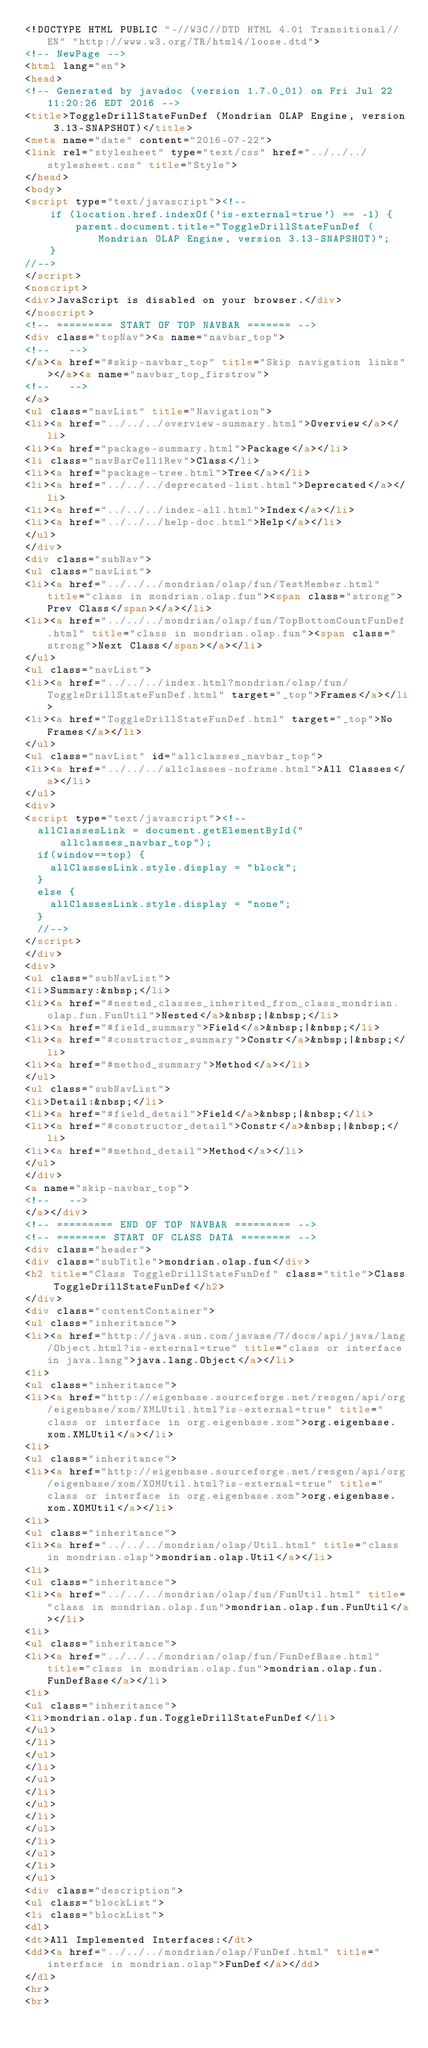<code> <loc_0><loc_0><loc_500><loc_500><_HTML_><!DOCTYPE HTML PUBLIC "-//W3C//DTD HTML 4.01 Transitional//EN" "http://www.w3.org/TR/html4/loose.dtd">
<!-- NewPage -->
<html lang="en">
<head>
<!-- Generated by javadoc (version 1.7.0_01) on Fri Jul 22 11:20:26 EDT 2016 -->
<title>ToggleDrillStateFunDef (Mondrian OLAP Engine, version 3.13-SNAPSHOT)</title>
<meta name="date" content="2016-07-22">
<link rel="stylesheet" type="text/css" href="../../../stylesheet.css" title="Style">
</head>
<body>
<script type="text/javascript"><!--
    if (location.href.indexOf('is-external=true') == -1) {
        parent.document.title="ToggleDrillStateFunDef (Mondrian OLAP Engine, version 3.13-SNAPSHOT)";
    }
//-->
</script>
<noscript>
<div>JavaScript is disabled on your browser.</div>
</noscript>
<!-- ========= START OF TOP NAVBAR ======= -->
<div class="topNav"><a name="navbar_top">
<!--   -->
</a><a href="#skip-navbar_top" title="Skip navigation links"></a><a name="navbar_top_firstrow">
<!--   -->
</a>
<ul class="navList" title="Navigation">
<li><a href="../../../overview-summary.html">Overview</a></li>
<li><a href="package-summary.html">Package</a></li>
<li class="navBarCell1Rev">Class</li>
<li><a href="package-tree.html">Tree</a></li>
<li><a href="../../../deprecated-list.html">Deprecated</a></li>
<li><a href="../../../index-all.html">Index</a></li>
<li><a href="../../../help-doc.html">Help</a></li>
</ul>
</div>
<div class="subNav">
<ul class="navList">
<li><a href="../../../mondrian/olap/fun/TestMember.html" title="class in mondrian.olap.fun"><span class="strong">Prev Class</span></a></li>
<li><a href="../../../mondrian/olap/fun/TopBottomCountFunDef.html" title="class in mondrian.olap.fun"><span class="strong">Next Class</span></a></li>
</ul>
<ul class="navList">
<li><a href="../../../index.html?mondrian/olap/fun/ToggleDrillStateFunDef.html" target="_top">Frames</a></li>
<li><a href="ToggleDrillStateFunDef.html" target="_top">No Frames</a></li>
</ul>
<ul class="navList" id="allclasses_navbar_top">
<li><a href="../../../allclasses-noframe.html">All Classes</a></li>
</ul>
<div>
<script type="text/javascript"><!--
  allClassesLink = document.getElementById("allclasses_navbar_top");
  if(window==top) {
    allClassesLink.style.display = "block";
  }
  else {
    allClassesLink.style.display = "none";
  }
  //-->
</script>
</div>
<div>
<ul class="subNavList">
<li>Summary:&nbsp;</li>
<li><a href="#nested_classes_inherited_from_class_mondrian.olap.fun.FunUtil">Nested</a>&nbsp;|&nbsp;</li>
<li><a href="#field_summary">Field</a>&nbsp;|&nbsp;</li>
<li><a href="#constructor_summary">Constr</a>&nbsp;|&nbsp;</li>
<li><a href="#method_summary">Method</a></li>
</ul>
<ul class="subNavList">
<li>Detail:&nbsp;</li>
<li><a href="#field_detail">Field</a>&nbsp;|&nbsp;</li>
<li><a href="#constructor_detail">Constr</a>&nbsp;|&nbsp;</li>
<li><a href="#method_detail">Method</a></li>
</ul>
</div>
<a name="skip-navbar_top">
<!--   -->
</a></div>
<!-- ========= END OF TOP NAVBAR ========= -->
<!-- ======== START OF CLASS DATA ======== -->
<div class="header">
<div class="subTitle">mondrian.olap.fun</div>
<h2 title="Class ToggleDrillStateFunDef" class="title">Class ToggleDrillStateFunDef</h2>
</div>
<div class="contentContainer">
<ul class="inheritance">
<li><a href="http://java.sun.com/javase/7/docs/api/java/lang/Object.html?is-external=true" title="class or interface in java.lang">java.lang.Object</a></li>
<li>
<ul class="inheritance">
<li><a href="http://eigenbase.sourceforge.net/resgen/api/org/eigenbase/xom/XMLUtil.html?is-external=true" title="class or interface in org.eigenbase.xom">org.eigenbase.xom.XMLUtil</a></li>
<li>
<ul class="inheritance">
<li><a href="http://eigenbase.sourceforge.net/resgen/api/org/eigenbase/xom/XOMUtil.html?is-external=true" title="class or interface in org.eigenbase.xom">org.eigenbase.xom.XOMUtil</a></li>
<li>
<ul class="inheritance">
<li><a href="../../../mondrian/olap/Util.html" title="class in mondrian.olap">mondrian.olap.Util</a></li>
<li>
<ul class="inheritance">
<li><a href="../../../mondrian/olap/fun/FunUtil.html" title="class in mondrian.olap.fun">mondrian.olap.fun.FunUtil</a></li>
<li>
<ul class="inheritance">
<li><a href="../../../mondrian/olap/fun/FunDefBase.html" title="class in mondrian.olap.fun">mondrian.olap.fun.FunDefBase</a></li>
<li>
<ul class="inheritance">
<li>mondrian.olap.fun.ToggleDrillStateFunDef</li>
</ul>
</li>
</ul>
</li>
</ul>
</li>
</ul>
</li>
</ul>
</li>
</ul>
</li>
</ul>
<div class="description">
<ul class="blockList">
<li class="blockList">
<dl>
<dt>All Implemented Interfaces:</dt>
<dd><a href="../../../mondrian/olap/FunDef.html" title="interface in mondrian.olap">FunDef</a></dd>
</dl>
<hr>
<br></code> 